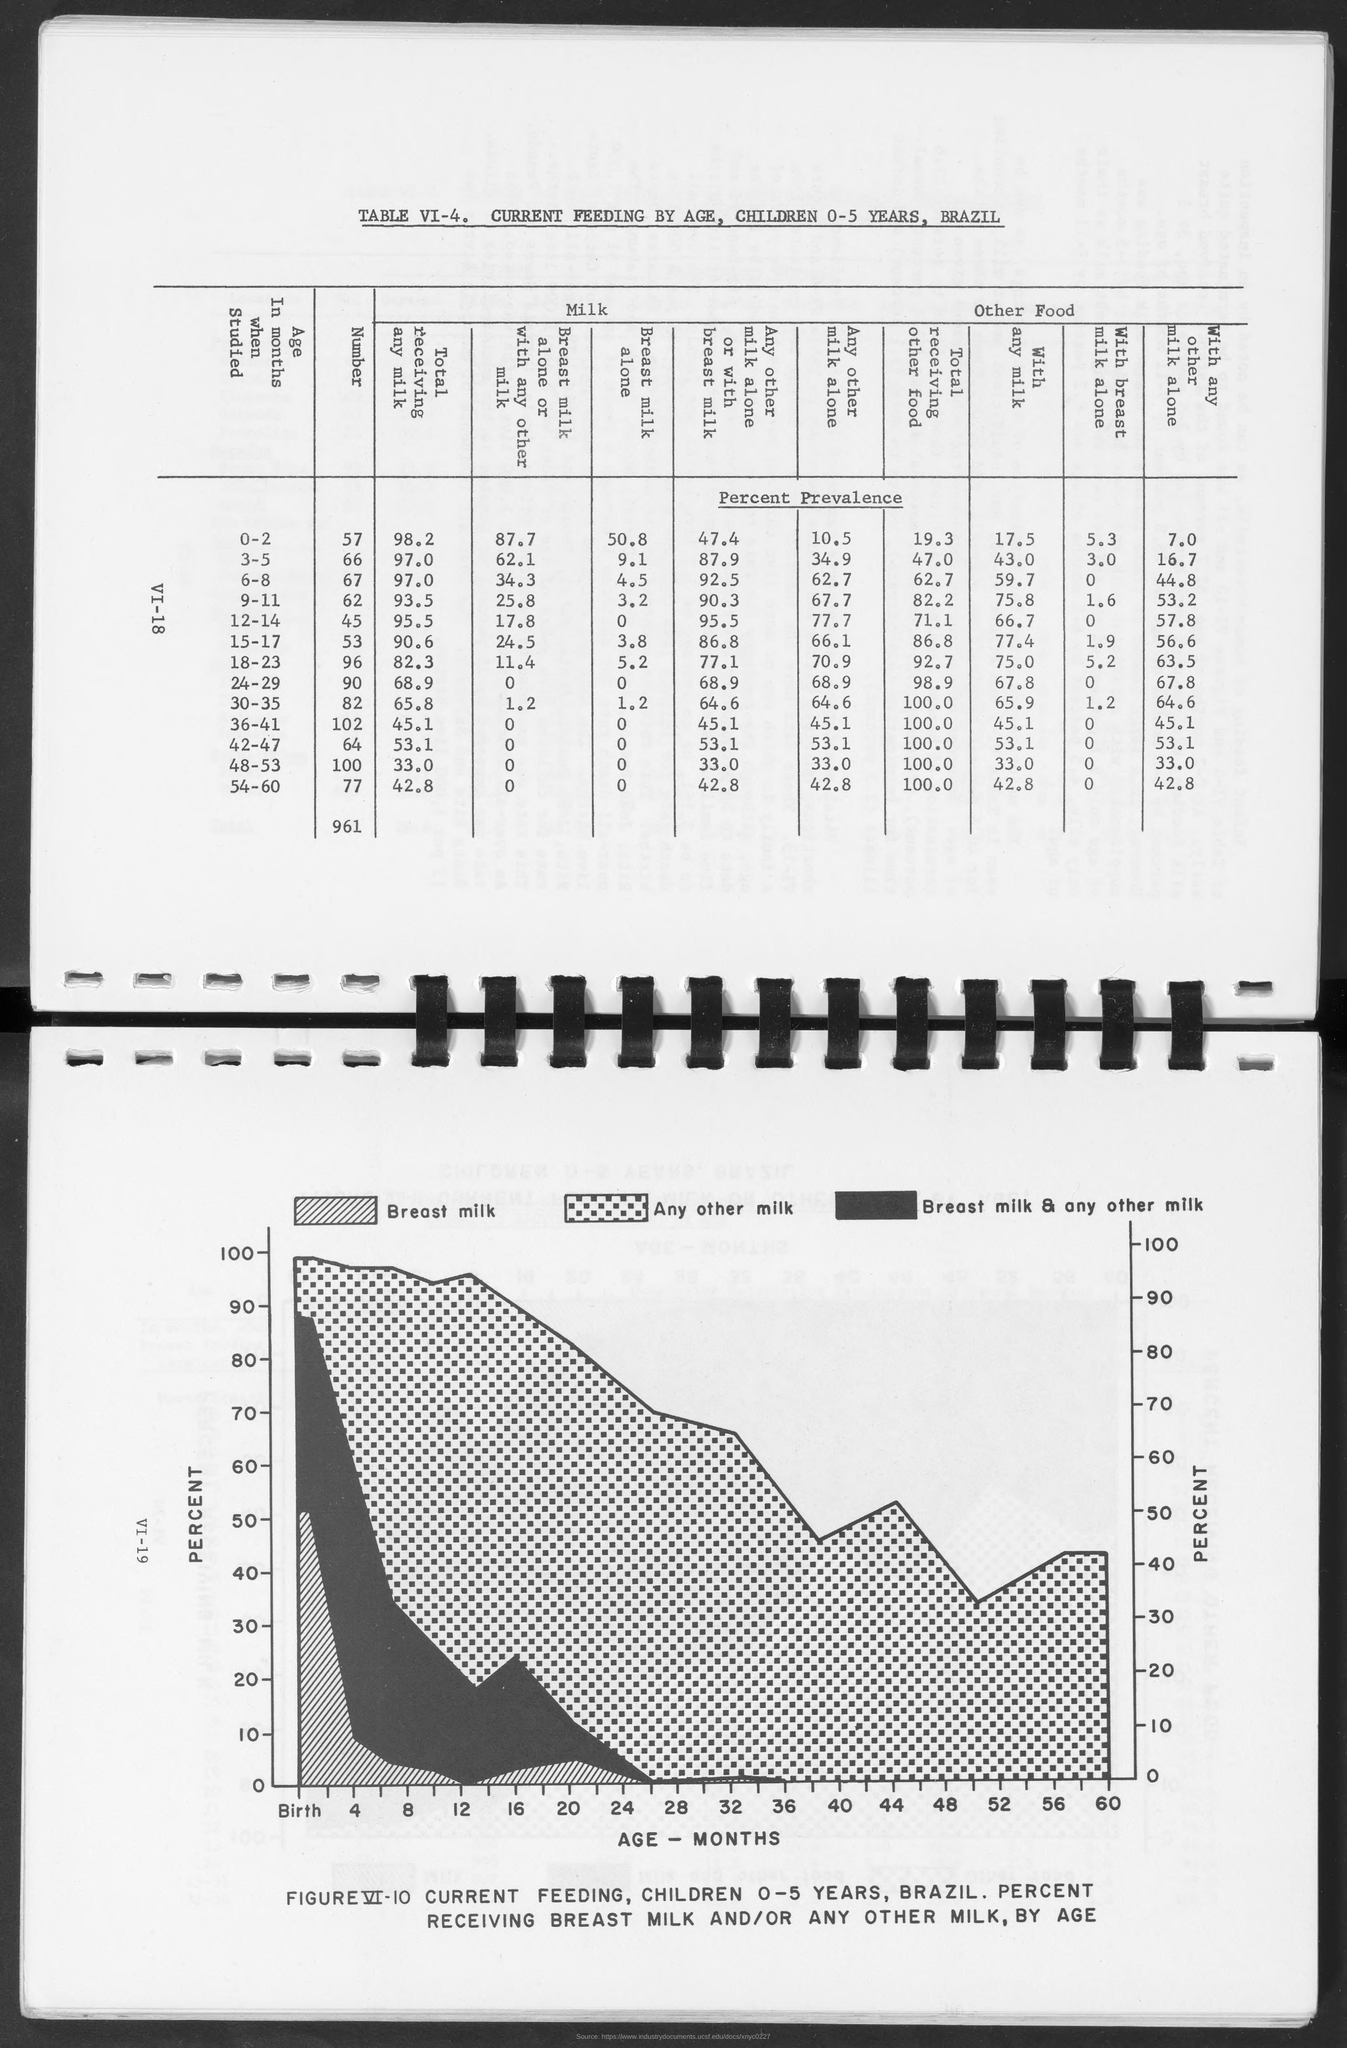What is plotted in the y-axis of the graph?
Your answer should be very brief. Percent. 